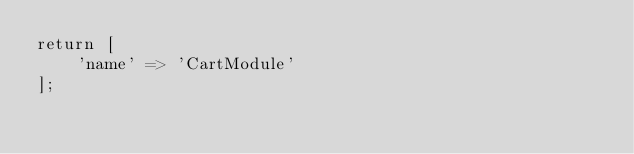Convert code to text. <code><loc_0><loc_0><loc_500><loc_500><_PHP_>return [
    'name' => 'CartModule'
];
</code> 